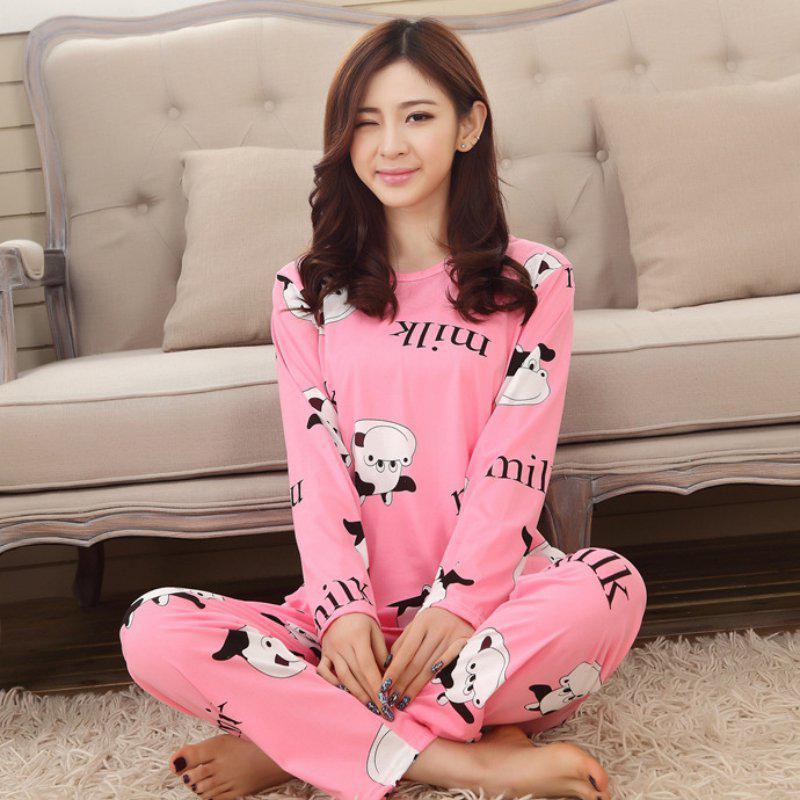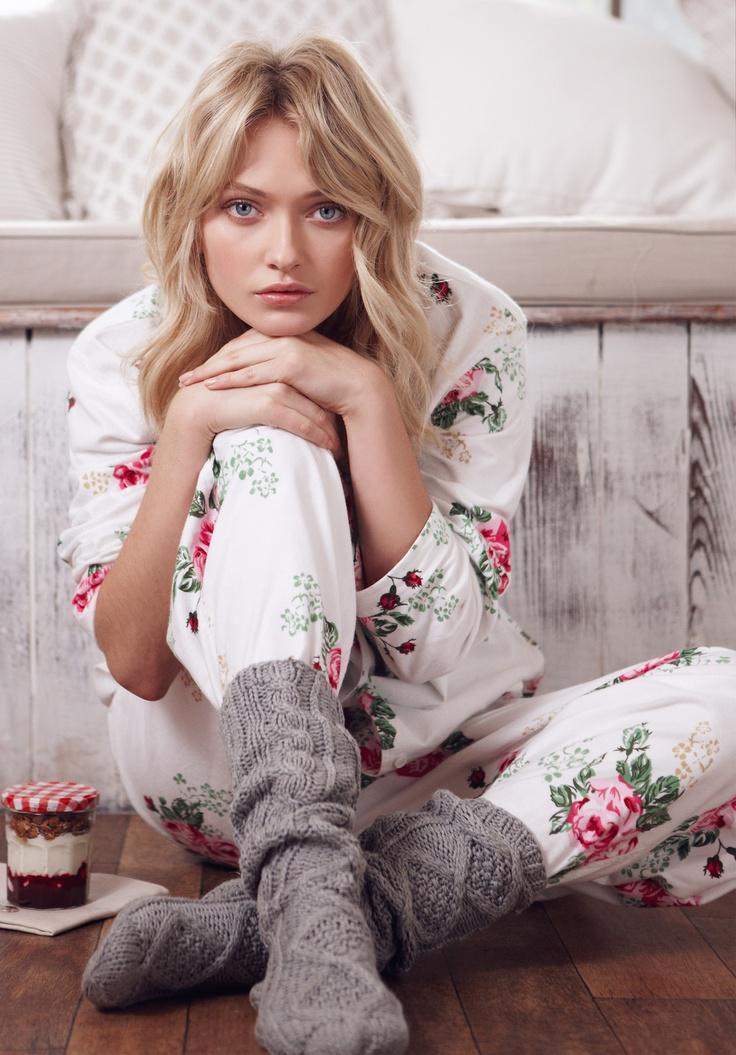The first image is the image on the left, the second image is the image on the right. Analyze the images presented: Is the assertion "The woman in one of the images has at least one hand on her knee." valid? Answer yes or no. Yes. The first image is the image on the left, the second image is the image on the right. For the images shown, is this caption "An image features a model wearing matching white pajamas printed with rosy flowers and green leaves." true? Answer yes or no. Yes. 